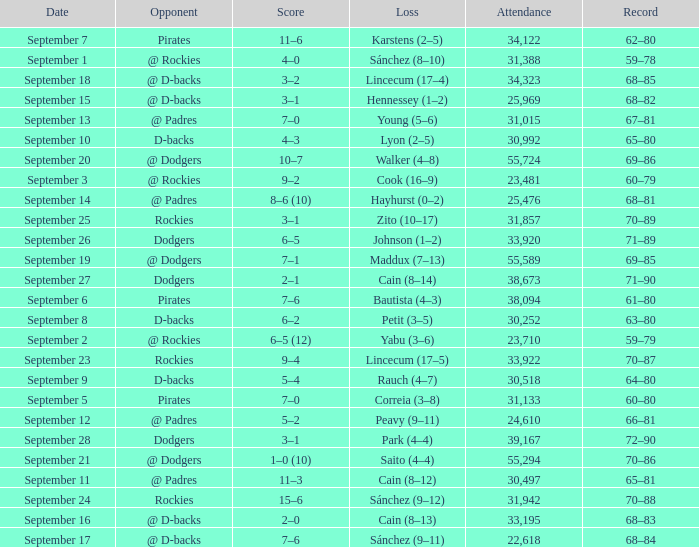What was the attendance on September 28? 39167.0. 